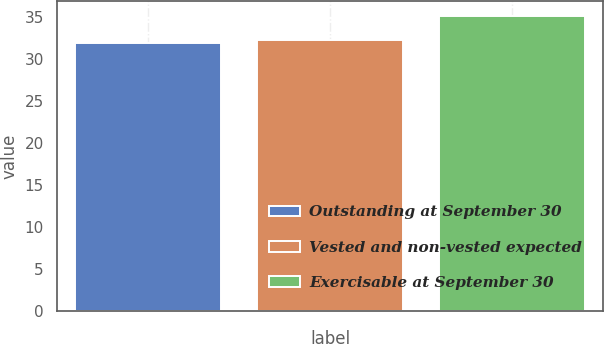Convert chart to OTSL. <chart><loc_0><loc_0><loc_500><loc_500><bar_chart><fcel>Outstanding at September 30<fcel>Vested and non-vested expected<fcel>Exercisable at September 30<nl><fcel>31.94<fcel>32.27<fcel>35.21<nl></chart> 